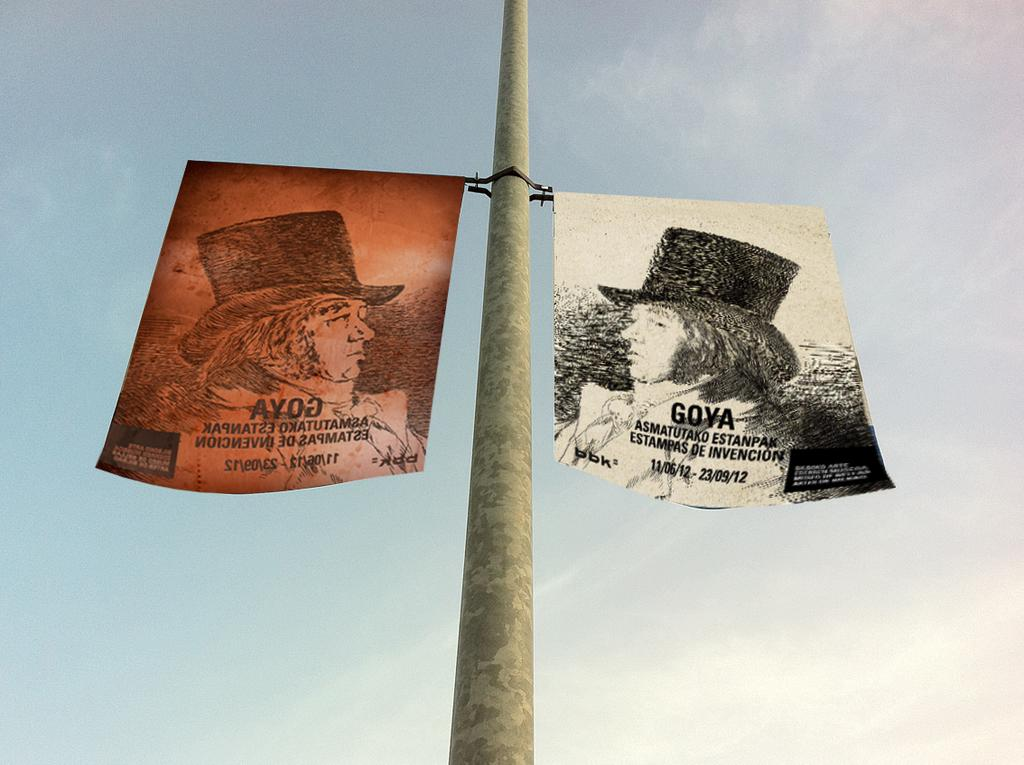What is hanging on the pole in the image? There are two pictures hanged on a pole in the image. What can be seen in the background of the image? The sky is visible in the image. How does the sky appear in the image? The sky appears to be cloudy in the image. How many mice are visible on the pole in the image? There are no mice present in the image; it only features two pictures hanging on a pole. What type of whip is being used to hang the pictures on the pole? There is no whip visible in the image; the pictures are simply hung on the pole. 